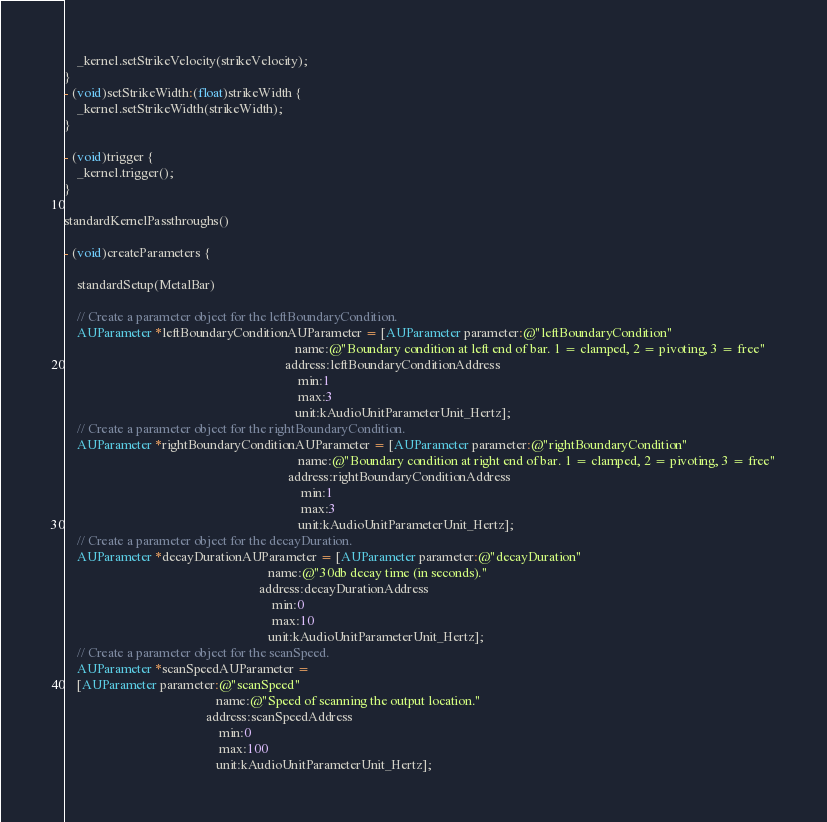Convert code to text. <code><loc_0><loc_0><loc_500><loc_500><_ObjectiveC_>    _kernel.setStrikeVelocity(strikeVelocity);
}
- (void)setStrikeWidth:(float)strikeWidth {
    _kernel.setStrikeWidth(strikeWidth);
}

- (void)trigger {
    _kernel.trigger();
}

standardKernelPassthroughs()

- (void)createParameters {

    standardSetup(MetalBar)

    // Create a parameter object for the leftBoundaryCondition.
    AUParameter *leftBoundaryConditionAUParameter = [AUParameter parameter:@"leftBoundaryCondition"
                                                                      name:@"Boundary condition at left end of bar. 1 = clamped, 2 = pivoting, 3 = free"
                                                                   address:leftBoundaryConditionAddress
                                                                       min:1
                                                                       max:3
                                                                      unit:kAudioUnitParameterUnit_Hertz];
    // Create a parameter object for the rightBoundaryCondition.
    AUParameter *rightBoundaryConditionAUParameter = [AUParameter parameter:@"rightBoundaryCondition"
                                                                       name:@"Boundary condition at right end of bar. 1 = clamped, 2 = pivoting, 3 = free"
                                                                    address:rightBoundaryConditionAddress
                                                                        min:1
                                                                        max:3
                                                                       unit:kAudioUnitParameterUnit_Hertz];
    // Create a parameter object for the decayDuration.
    AUParameter *decayDurationAUParameter = [AUParameter parameter:@"decayDuration"
                                                              name:@"30db decay time (in seconds)."
                                                           address:decayDurationAddress
                                                               min:0
                                                               max:10
                                                              unit:kAudioUnitParameterUnit_Hertz];
    // Create a parameter object for the scanSpeed.
    AUParameter *scanSpeedAUParameter =
    [AUParameter parameter:@"scanSpeed"
                                              name:@"Speed of scanning the output location."
                                           address:scanSpeedAddress
                                               min:0
                                               max:100
                                              unit:kAudioUnitParameterUnit_Hertz];</code> 